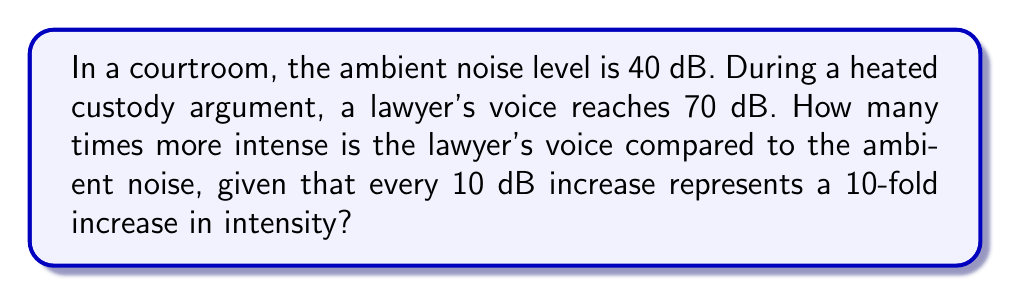Give your solution to this math problem. Let's approach this step-by-step:

1) The difference in decibel levels is:
   $70 \text{ dB} - 40 \text{ dB} = 30 \text{ dB}$

2) We're told that every 10 dB increase represents a 10-fold increase in intensity. We can express this mathematically as:

   $$\text{Intensity ratio} = 10^{\frac{\text{dB difference}}{10}}$$

3) Plugging in our 30 dB difference:

   $$\text{Intensity ratio} = 10^{\frac{30}{10}} = 10^3 = 1000$$

4) This means the lawyer's voice is 1000 times more intense than the ambient noise.

This logarithmic scale is crucial in courtroom settings to ensure that all participants can be heard clearly while maintaining appropriate volume levels.
Answer: 1000 times 